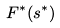<formula> <loc_0><loc_0><loc_500><loc_500>F ^ { * } ( s ^ { * } )</formula> 